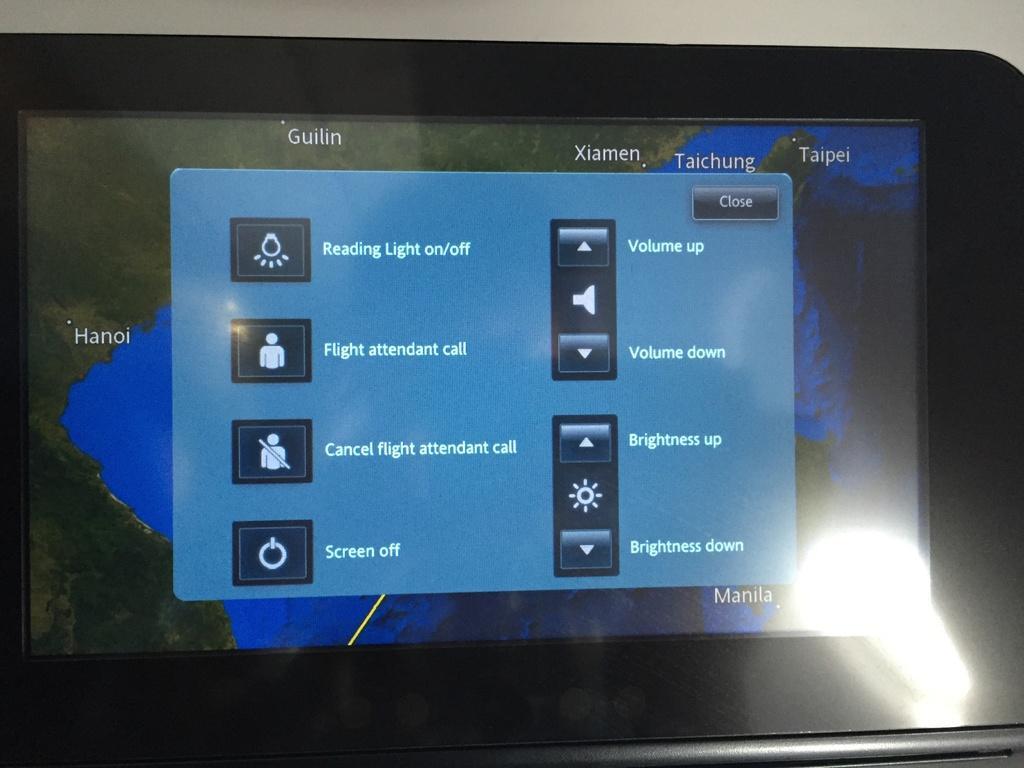Can you describe this image briefly? There is a black color tab having a screen in which there is a menu. On the right side bottom corner, there is a flash light. And the background is white in color. 